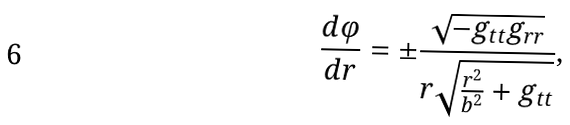Convert formula to latex. <formula><loc_0><loc_0><loc_500><loc_500>\frac { d \varphi } { d r } = \pm \frac { \sqrt { - g _ { t t } g _ { r r } } } { r \sqrt { \frac { r ^ { 2 } } { b ^ { 2 } } + g _ { t t } } } ,</formula> 